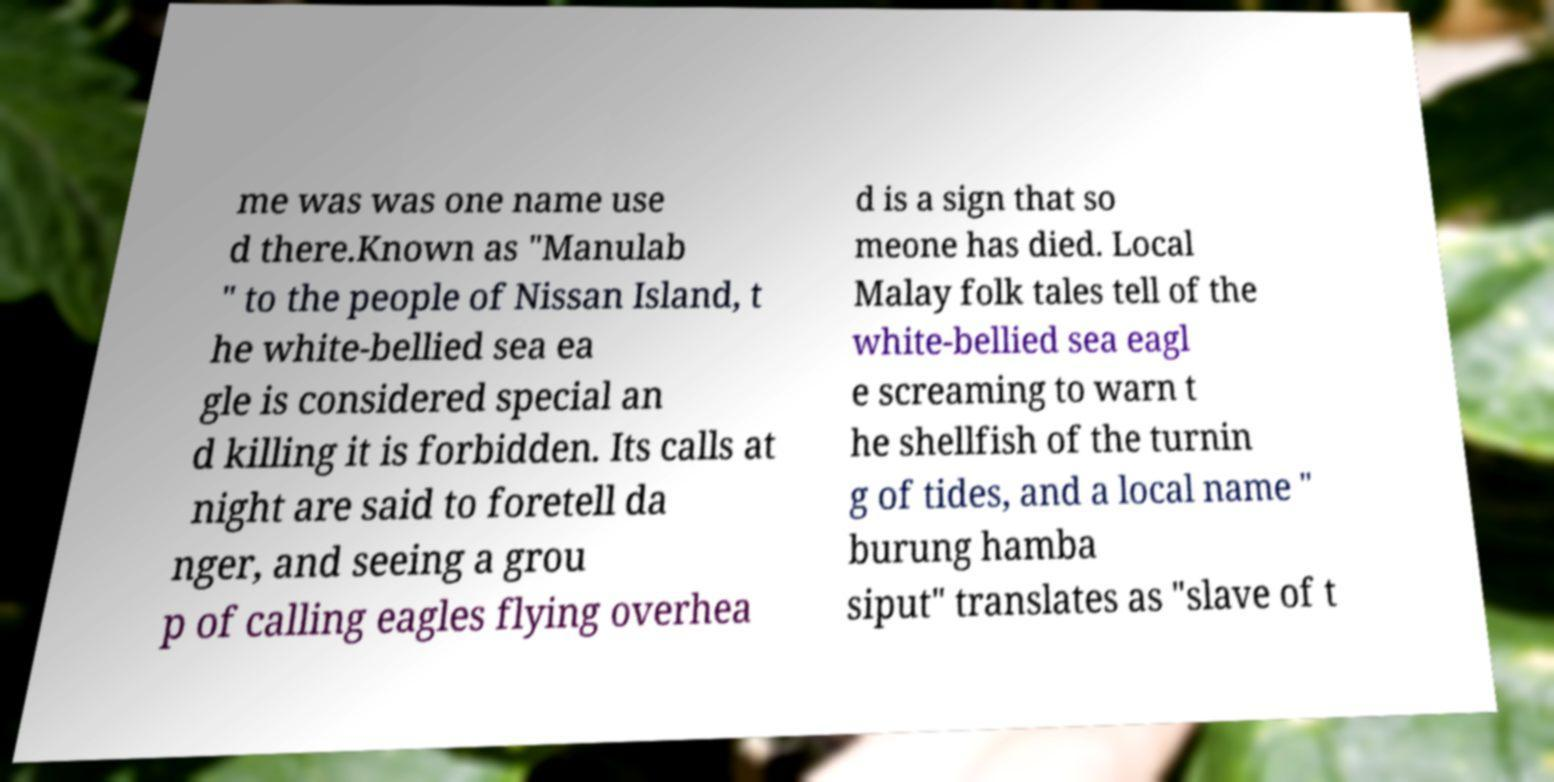I need the written content from this picture converted into text. Can you do that? me was was one name use d there.Known as "Manulab " to the people of Nissan Island, t he white-bellied sea ea gle is considered special an d killing it is forbidden. Its calls at night are said to foretell da nger, and seeing a grou p of calling eagles flying overhea d is a sign that so meone has died. Local Malay folk tales tell of the white-bellied sea eagl e screaming to warn t he shellfish of the turnin g of tides, and a local name " burung hamba siput" translates as "slave of t 